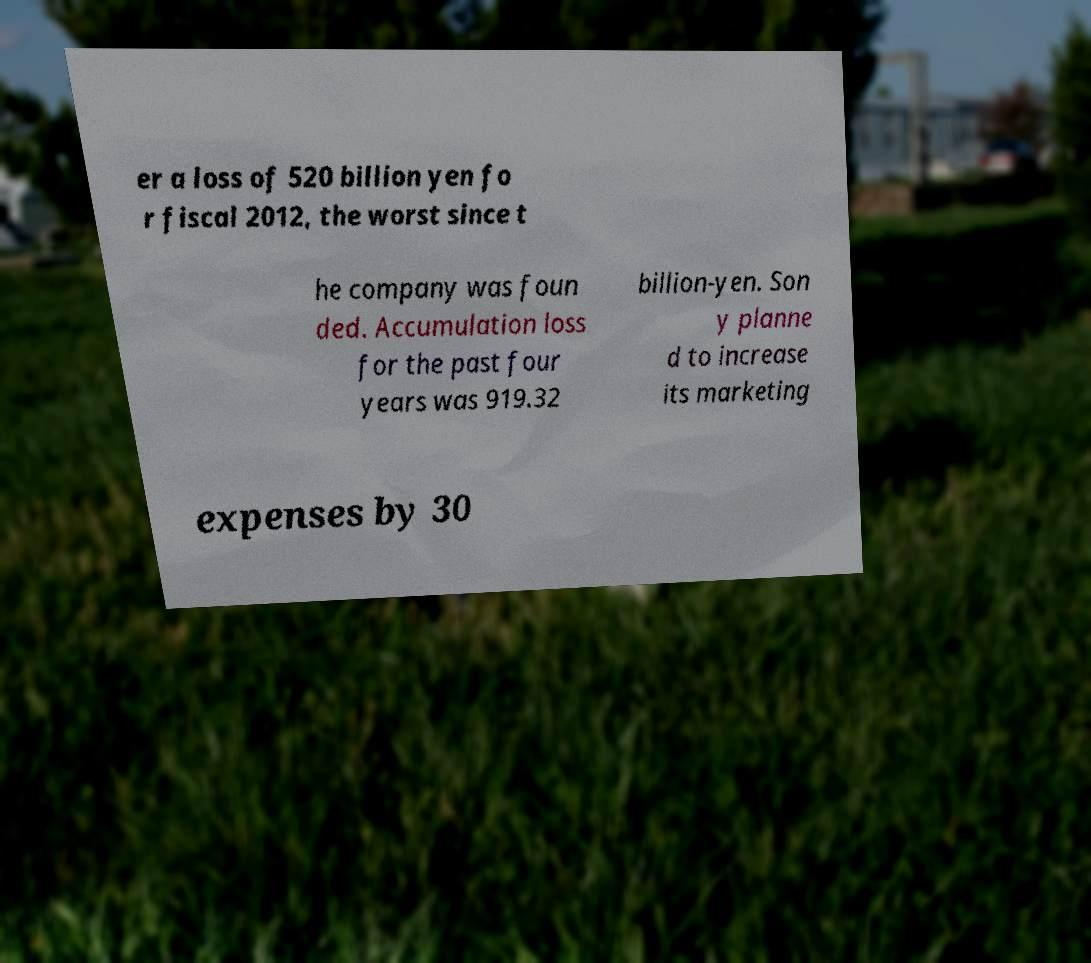Can you read and provide the text displayed in the image?This photo seems to have some interesting text. Can you extract and type it out for me? er a loss of 520 billion yen fo r fiscal 2012, the worst since t he company was foun ded. Accumulation loss for the past four years was 919.32 billion-yen. Son y planne d to increase its marketing expenses by 30 